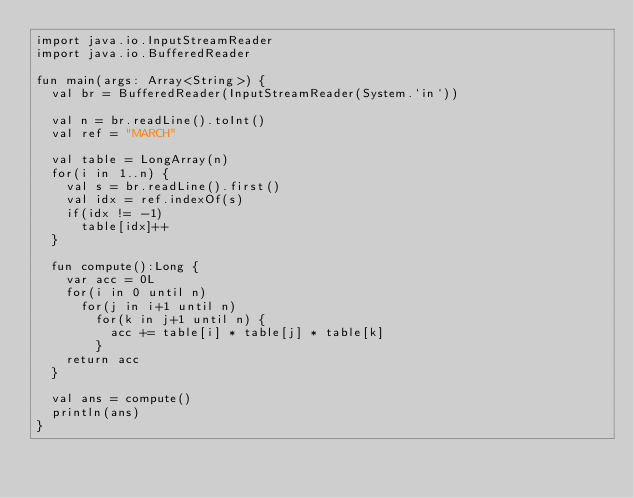<code> <loc_0><loc_0><loc_500><loc_500><_Kotlin_>import java.io.InputStreamReader
import java.io.BufferedReader

fun main(args: Array<String>) {
  val br = BufferedReader(InputStreamReader(System.`in`))

  val n = br.readLine().toInt()
  val ref = "MARCH"

  val table = LongArray(n)
  for(i in 1..n) {
    val s = br.readLine().first()
    val idx = ref.indexOf(s)
    if(idx != -1)
      table[idx]++
  }

  fun compute():Long {
    var acc = 0L
    for(i in 0 until n)
      for(j in i+1 until n)
        for(k in j+1 until n) {
          acc += table[i] * table[j] * table[k]
        }
    return acc
  }

  val ans = compute()
  println(ans)
}</code> 